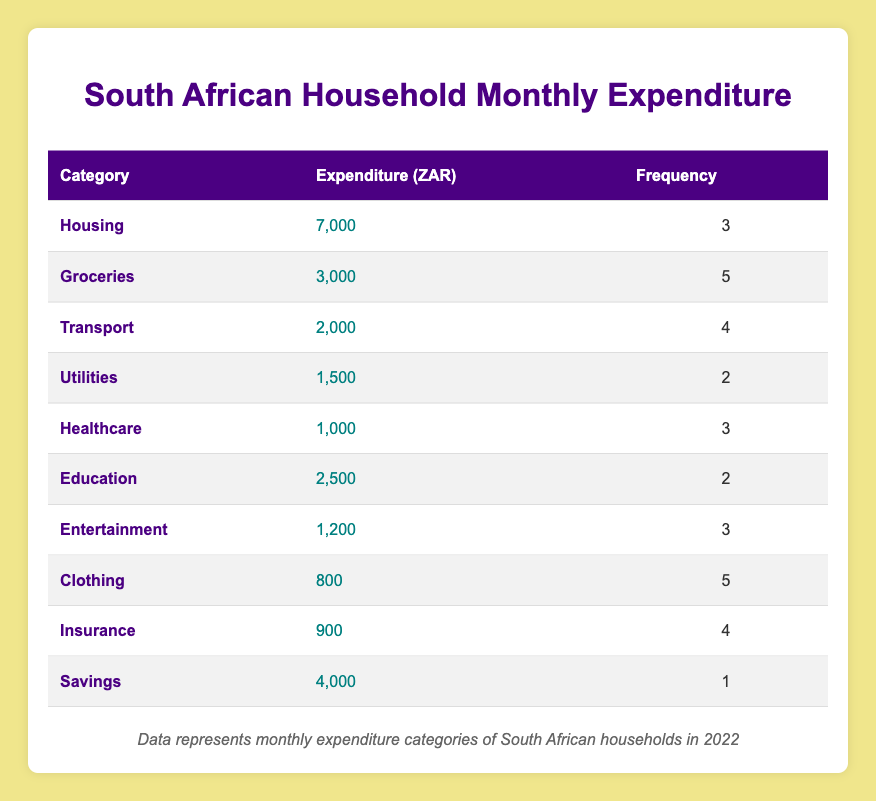What is the highest expenditure category? By looking at the "Expenditure (ZAR)" column, Housing has the highest value at 7000 ZAR.
Answer: Housing How many households reported spending on Utilities? The table indicates that 2 households reported spending in the Utilities category. This is found in the "Frequency" column next to Utilities.
Answer: 2 What is the total expenditure amount for Groceries and Transport combined? To find the total, I add the expenditure for Groceries (3000 ZAR) and Transport (2000 ZAR). Thus, 3000 + 2000 = 5000 ZAR.
Answer: 5000 ZAR Is the expenditure on Healthcare greater than that on Education? Comparing the expenditure amounts, Healthcare is 1000 ZAR while Education is 2500 ZAR. Since 1000 ZAR is less than 2500 ZAR, the statement is false.
Answer: No What is the average expenditure across all categories? First, I sum up all expenditure amounts: 7000 + 3000 + 2000 + 1500 + 1000 + 2500 + 1200 + 800 + 900 + 4000 = 20200 ZAR. There are 10 categories, so the average is 20200 / 10 = 2020 ZAR.
Answer: 2020 ZAR How many more households spend on Clothing compared to Healthcare? Looking at the "Frequency" column, Clothing has 5 households while Healthcare has 3. To find the difference, I calculate 5 - 3 = 2.
Answer: 2 Which expenditure category has the lowest count of households, and how many are they? By checking the "Frequency" column, Savings has the lowest count with only 1 household reported.
Answer: Savings, 1 Does more than half of the categories have an expenditure over 2000 ZAR? The categories with expenditure over 2000 ZAR are Housing, Groceries, and Transport, totaling 3 out of 10 categories. Thus, this means less than half do.
Answer: No What percentage of the total expenditure is allocated to Housing? Housing expenditure is 7000 ZAR. First, we calculate total expenditure (20200 ZAR) to find the percentage: (7000 / 20200) * 100 = approximately 34.65%.
Answer: 34.65% 